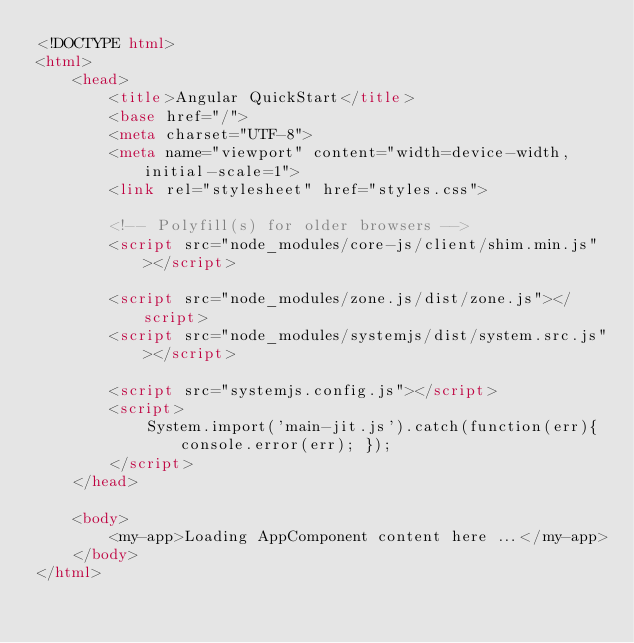Convert code to text. <code><loc_0><loc_0><loc_500><loc_500><_HTML_><!DOCTYPE html>
<html>
	<head>
		<title>Angular QuickStart</title>
		<base href="/">
		<meta charset="UTF-8">
		<meta name="viewport" content="width=device-width, initial-scale=1">
		<link rel="stylesheet" href="styles.css">

		<!-- Polyfill(s) for older browsers -->
		<script src="node_modules/core-js/client/shim.min.js"></script>

		<script src="node_modules/zone.js/dist/zone.js"></script>
		<script src="node_modules/systemjs/dist/system.src.js"></script>

		<script src="systemjs.config.js"></script>
		<script>
			System.import('main-jit.js').catch(function(err){ console.error(err); });
		</script>
	</head>

	<body>
		<my-app>Loading AppComponent content here ...</my-app>
	</body>
</html>
</code> 